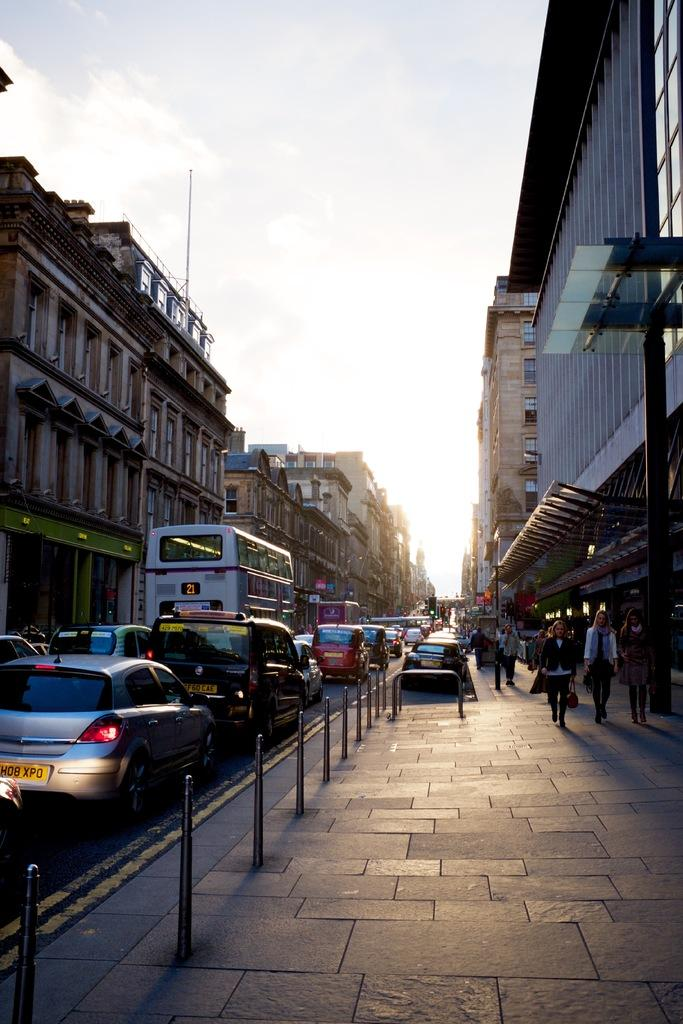<image>
Relay a brief, clear account of the picture shown. A street scene, a bus with the number 21 on it is visible. 